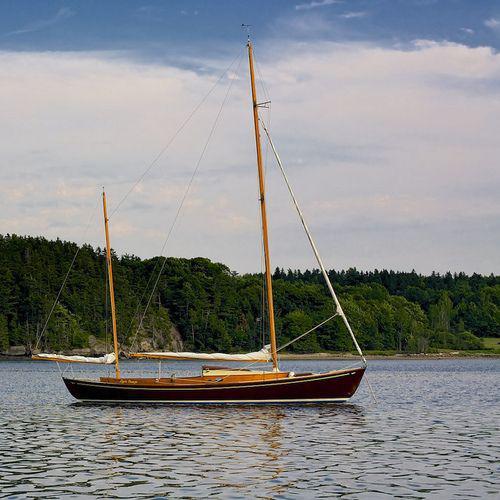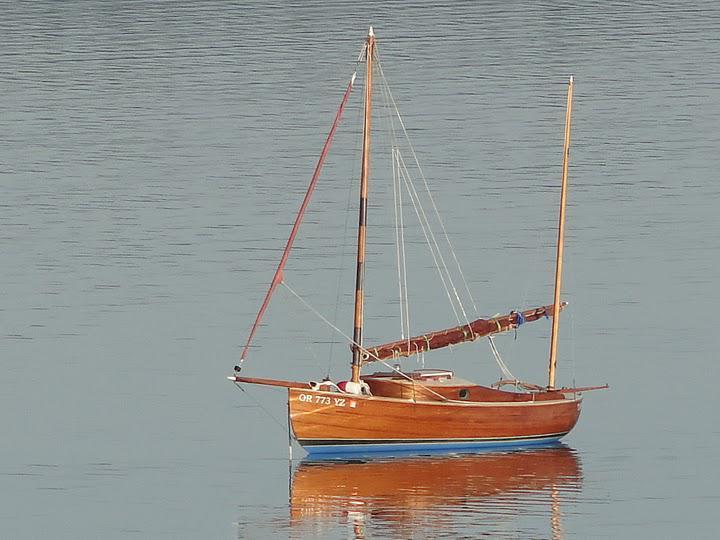The first image is the image on the left, the second image is the image on the right. For the images displayed, is the sentence "Each sailboat has two white sails." factually correct? Answer yes or no. No. 